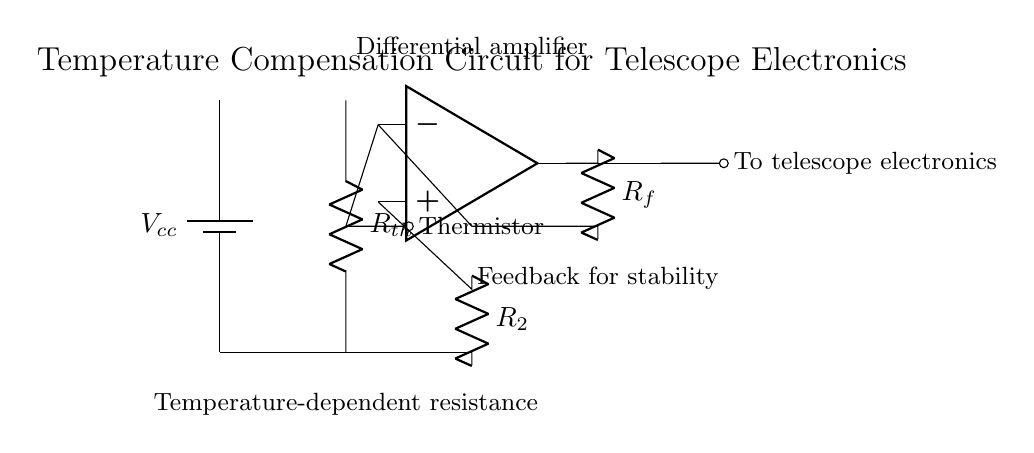What type of sensor is used in this circuit? The circuit includes a thermistor, which is a type of temperature sensor that changes its resistance based on temperature variations. This is indicated by the label next to the component.
Answer: Thermistor What is the purpose of the operational amplifier in this circuit? The operational amplifier is used to amplify the voltage difference from the thermistor, enabling precise control over the output voltage sent to the telescope electronics. This is indicated by its position and role in the feedback loop.
Answer: Voltage amplification What is the value of the feedback resistor labeled in this circuit? The feedback resistor is labeled as R_f. Its actual value isn't specified in the diagram, but its purpose is to stabilize the output by controlling gain in the feedback network.
Answer: R_f How many resistors are present in the circuit? The circuit diagram shows three resistors: R_th (thermistor), R_2, and R_f. Each serves a specific purpose in the interaction between the thermistor and the operational amplifier.
Answer: Three What does the output of the operational amplifier connect to? The output of the operational amplifier connects directly to the telescope electronics via a short, as indicated by the connection line leading to it from the op-amp.
Answer: Telescope electronics What role does the thermistor play in temperature compensation? The thermistor alters its resistance with temperature change, allowing the operational amplifier to adjust the output voltage and maintain performance despite varying ambient conditions. This is inferred from its connection to the op-amp and the purpose of the circuit.
Answer: Temperature measurement 